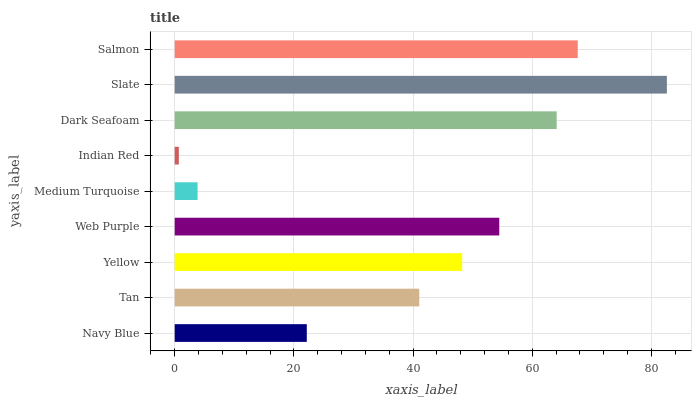Is Indian Red the minimum?
Answer yes or no. Yes. Is Slate the maximum?
Answer yes or no. Yes. Is Tan the minimum?
Answer yes or no. No. Is Tan the maximum?
Answer yes or no. No. Is Tan greater than Navy Blue?
Answer yes or no. Yes. Is Navy Blue less than Tan?
Answer yes or no. Yes. Is Navy Blue greater than Tan?
Answer yes or no. No. Is Tan less than Navy Blue?
Answer yes or no. No. Is Yellow the high median?
Answer yes or no. Yes. Is Yellow the low median?
Answer yes or no. Yes. Is Salmon the high median?
Answer yes or no. No. Is Tan the low median?
Answer yes or no. No. 